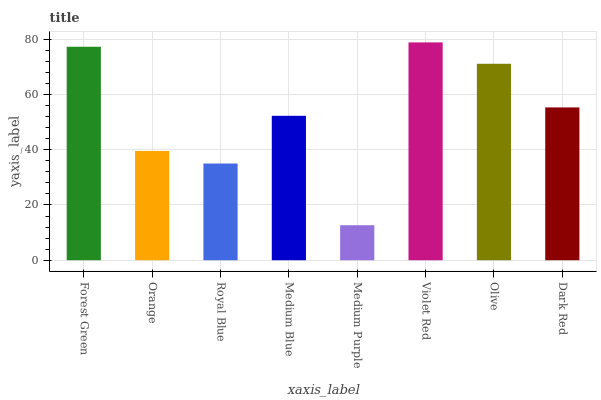Is Medium Purple the minimum?
Answer yes or no. Yes. Is Violet Red the maximum?
Answer yes or no. Yes. Is Orange the minimum?
Answer yes or no. No. Is Orange the maximum?
Answer yes or no. No. Is Forest Green greater than Orange?
Answer yes or no. Yes. Is Orange less than Forest Green?
Answer yes or no. Yes. Is Orange greater than Forest Green?
Answer yes or no. No. Is Forest Green less than Orange?
Answer yes or no. No. Is Dark Red the high median?
Answer yes or no. Yes. Is Medium Blue the low median?
Answer yes or no. Yes. Is Medium Purple the high median?
Answer yes or no. No. Is Royal Blue the low median?
Answer yes or no. No. 